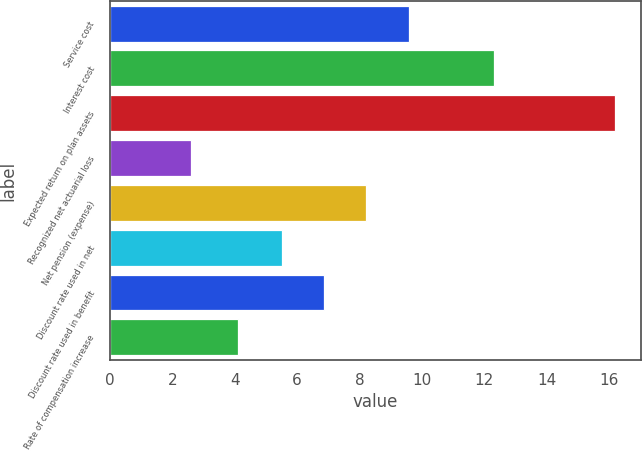Convert chart to OTSL. <chart><loc_0><loc_0><loc_500><loc_500><bar_chart><fcel>Service cost<fcel>Interest cost<fcel>Expected return on plan assets<fcel>Recognized net actuarial loss<fcel>Net pension (expense)<fcel>Discount rate used in net<fcel>Discount rate used in benefit<fcel>Rate of compensation increase<nl><fcel>9.58<fcel>12.3<fcel>16.2<fcel>2.6<fcel>8.22<fcel>5.5<fcel>6.86<fcel>4.1<nl></chart> 